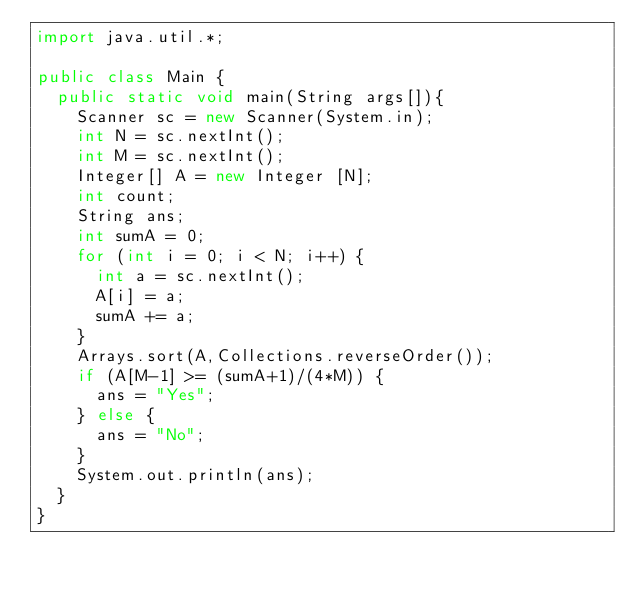<code> <loc_0><loc_0><loc_500><loc_500><_Java_>import java.util.*;
 
public class Main {
  public static void main(String args[]){
		Scanner sc = new Scanner(System.in);
		int N = sc.nextInt();
		int M = sc.nextInt();
		Integer[] A = new Integer [N];
		int count;
		String ans;
		int sumA = 0;
		for (int i = 0; i < N; i++) {
			int a = sc.nextInt();
			A[i] = a;
			sumA += a;
		}
		Arrays.sort(A,Collections.reverseOrder());
		if (A[M-1] >= (sumA+1)/(4*M)) {
      ans = "Yes";
		} else {
			ans = "No";
		}
		System.out.println(ans);
  }
}</code> 